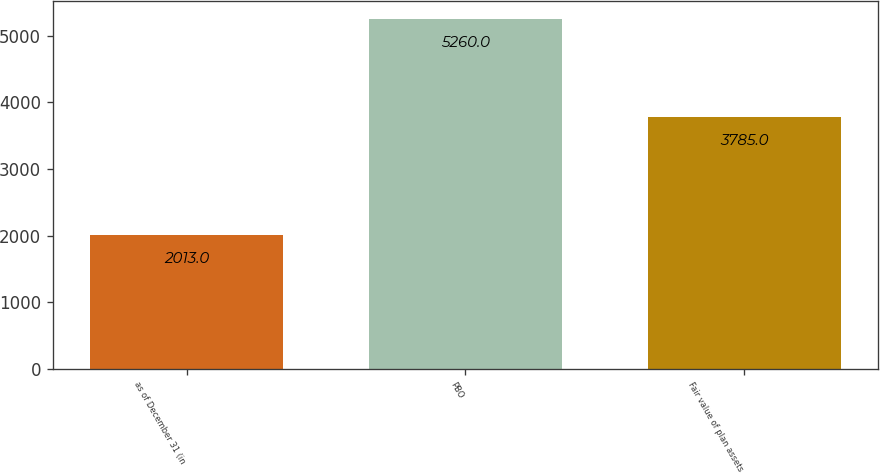Convert chart to OTSL. <chart><loc_0><loc_0><loc_500><loc_500><bar_chart><fcel>as of December 31 (in<fcel>PBO<fcel>Fair value of plan assets<nl><fcel>2013<fcel>5260<fcel>3785<nl></chart> 